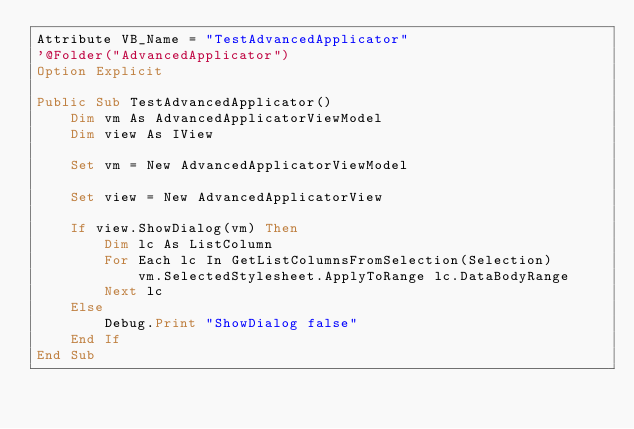<code> <loc_0><loc_0><loc_500><loc_500><_VisualBasic_>Attribute VB_Name = "TestAdvancedApplicator"
'@Folder("AdvancedApplicator")
Option Explicit

Public Sub TestAdvancedApplicator()
    Dim vm As AdvancedApplicatorViewModel
    Dim view As IView
    
    Set vm = New AdvancedApplicatorViewModel
    
    Set view = New AdvancedApplicatorView
    
    If view.ShowDialog(vm) Then
        Dim lc As ListColumn
        For Each lc In GetListColumnsFromSelection(Selection)
            vm.SelectedStylesheet.ApplyToRange lc.DataBodyRange
        Next lc
    Else
        Debug.Print "ShowDialog false"
    End If
End Sub
</code> 